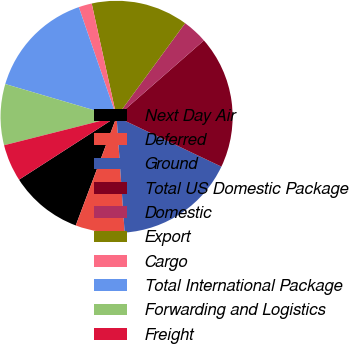<chart> <loc_0><loc_0><loc_500><loc_500><pie_chart><fcel>Next Day Air<fcel>Deferred<fcel>Ground<fcel>Total US Domestic Package<fcel>Domestic<fcel>Export<fcel>Cargo<fcel>Total International Package<fcel>Forwarding and Logistics<fcel>Freight<nl><fcel>10.17%<fcel>6.83%<fcel>16.83%<fcel>18.5%<fcel>3.5%<fcel>13.5%<fcel>1.84%<fcel>15.16%<fcel>8.5%<fcel>5.17%<nl></chart> 